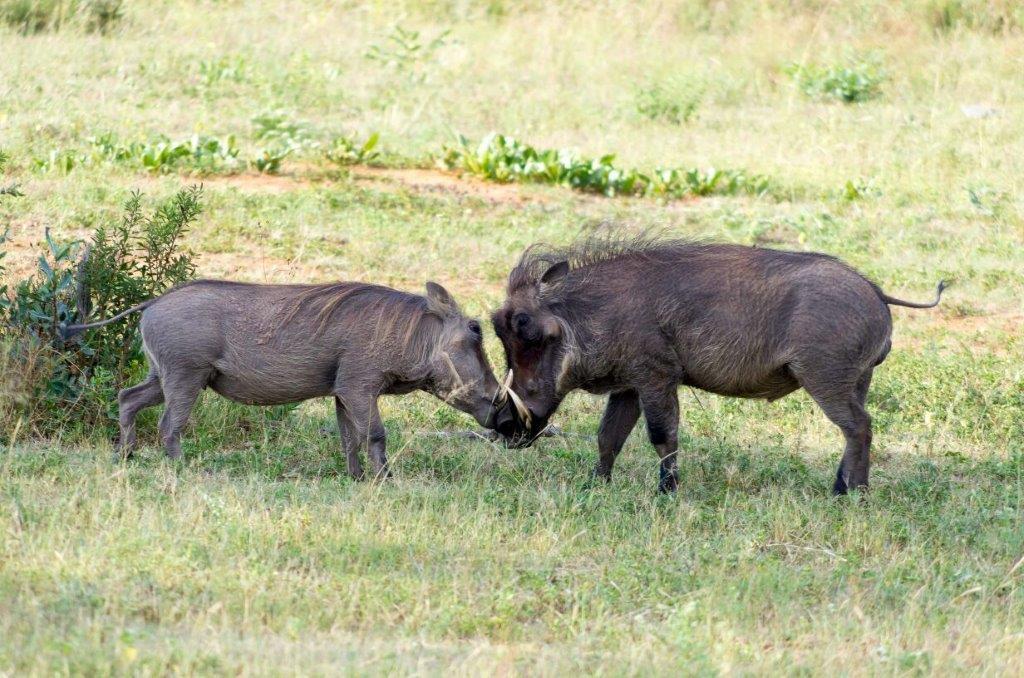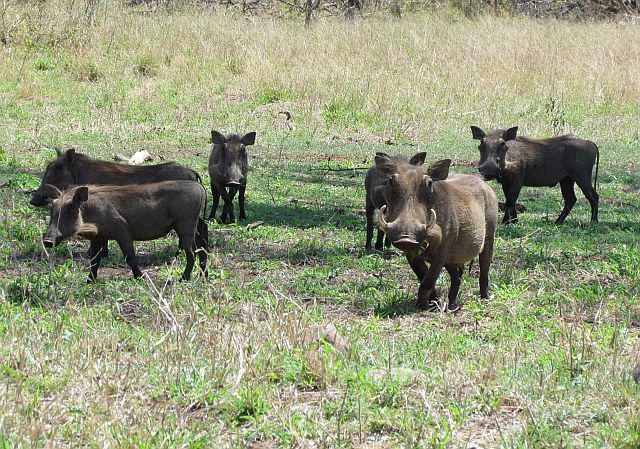The first image is the image on the left, the second image is the image on the right. For the images displayed, is the sentence "There are exactly five animals in the image on the right." factually correct? Answer yes or no. No. 